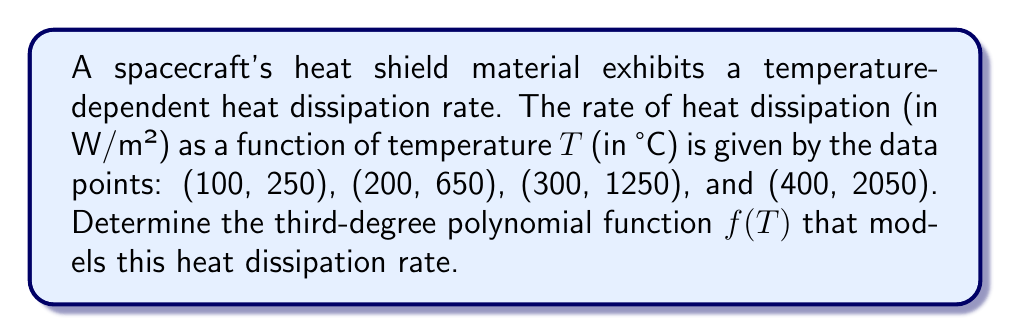Could you help me with this problem? To find the third-degree polynomial function $f(T)$ that fits the given data points, we'll use the method of finite differences.

Step 1: Calculate the first-order differences.
$$\begin{align*}
\Delta_1(100) &= 650 - 250 = 400 \\
\Delta_1(200) &= 1250 - 650 = 600 \\
\Delta_1(300) &= 2050 - 1250 = 800
\end{align*}$$

Step 2: Calculate the second-order differences.
$$\begin{align*}
\Delta_2(100) &= 600 - 400 = 200 \\
\Delta_2(200) &= 800 - 600 = 200
\end{align*}$$

Step 3: Calculate the third-order difference.
$$\Delta_3(100) = 200 - 200 = 0$$

Since the third-order difference is constant (0), we confirm that a third-degree polynomial will fit the data exactly.

Step 4: Set up the general form of the polynomial.
$$f(T) = aT^3 + bT^2 + cT + d$$

Step 5: Calculate the coefficients.
$a = \frac{\Delta_3(100)}{6h^3} = \frac{0}{6(100)^3} = 0$

$b = \frac{\Delta_2(100)}{2h^2} = \frac{200}{2(100)^2} = 0.01$

$c = \frac{\Delta_1(100) - 3h^2b}{h} = \frac{400 - 3(100)^2(0.01)}{100} = 1$

$d = f(100) - 100^3a - 100^2b - 100c = 250 - 0 - 100 - 100 = 50$

Step 6: Write the final polynomial function.
$$f(T) = 0.01T^2 + T + 50$$
Answer: $f(T) = 0.01T^2 + T + 50$ 